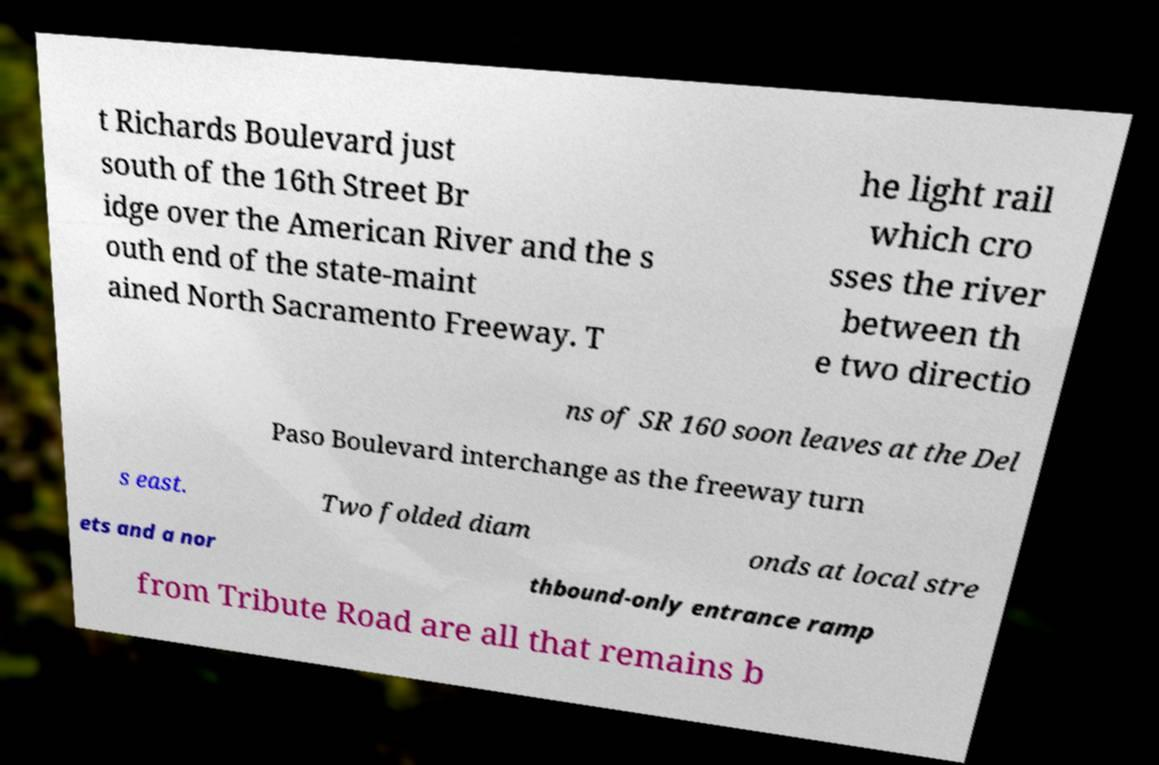Could you assist in decoding the text presented in this image and type it out clearly? t Richards Boulevard just south of the 16th Street Br idge over the American River and the s outh end of the state-maint ained North Sacramento Freeway. T he light rail which cro sses the river between th e two directio ns of SR 160 soon leaves at the Del Paso Boulevard interchange as the freeway turn s east. Two folded diam onds at local stre ets and a nor thbound-only entrance ramp from Tribute Road are all that remains b 